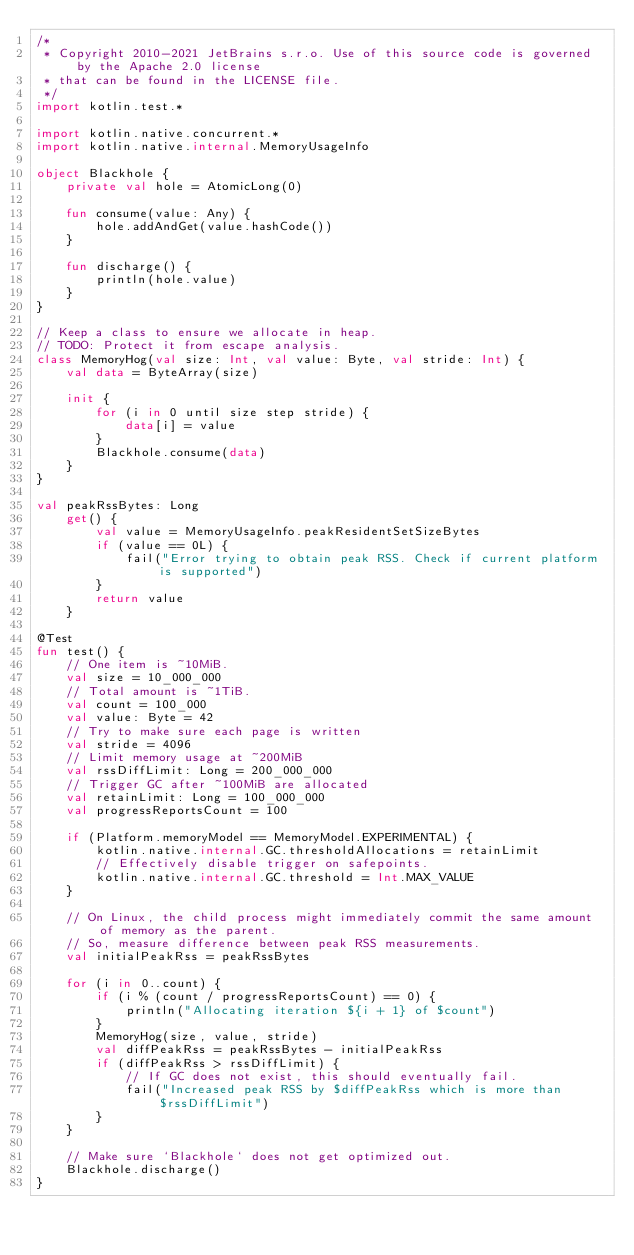Convert code to text. <code><loc_0><loc_0><loc_500><loc_500><_Kotlin_>/*
 * Copyright 2010-2021 JetBrains s.r.o. Use of this source code is governed by the Apache 2.0 license
 * that can be found in the LICENSE file.
 */
import kotlin.test.*

import kotlin.native.concurrent.*
import kotlin.native.internal.MemoryUsageInfo

object Blackhole {
    private val hole = AtomicLong(0)

    fun consume(value: Any) {
        hole.addAndGet(value.hashCode())
    }

    fun discharge() {
        println(hole.value)
    }
}

// Keep a class to ensure we allocate in heap.
// TODO: Protect it from escape analysis.
class MemoryHog(val size: Int, val value: Byte, val stride: Int) {
    val data = ByteArray(size)

    init {
        for (i in 0 until size step stride) {
            data[i] = value
        }
        Blackhole.consume(data)
    }
}

val peakRssBytes: Long
    get() {
        val value = MemoryUsageInfo.peakResidentSetSizeBytes
        if (value == 0L) {
            fail("Error trying to obtain peak RSS. Check if current platform is supported")
        }
        return value
    }

@Test
fun test() {
    // One item is ~10MiB.
    val size = 10_000_000
    // Total amount is ~1TiB.
    val count = 100_000
    val value: Byte = 42
    // Try to make sure each page is written
    val stride = 4096
    // Limit memory usage at ~200MiB
    val rssDiffLimit: Long = 200_000_000
    // Trigger GC after ~100MiB are allocated
    val retainLimit: Long = 100_000_000
    val progressReportsCount = 100

    if (Platform.memoryModel == MemoryModel.EXPERIMENTAL) {
        kotlin.native.internal.GC.thresholdAllocations = retainLimit
        // Effectively disable trigger on safepoints.
        kotlin.native.internal.GC.threshold = Int.MAX_VALUE
    }

    // On Linux, the child process might immediately commit the same amount of memory as the parent.
    // So, measure difference between peak RSS measurements.
    val initialPeakRss = peakRssBytes

    for (i in 0..count) {
        if (i % (count / progressReportsCount) == 0) {
            println("Allocating iteration ${i + 1} of $count")
        }
        MemoryHog(size, value, stride)
        val diffPeakRss = peakRssBytes - initialPeakRss
        if (diffPeakRss > rssDiffLimit) {
            // If GC does not exist, this should eventually fail.
            fail("Increased peak RSS by $diffPeakRss which is more than $rssDiffLimit")
        }
    }

    // Make sure `Blackhole` does not get optimized out.
    Blackhole.discharge()
}
</code> 